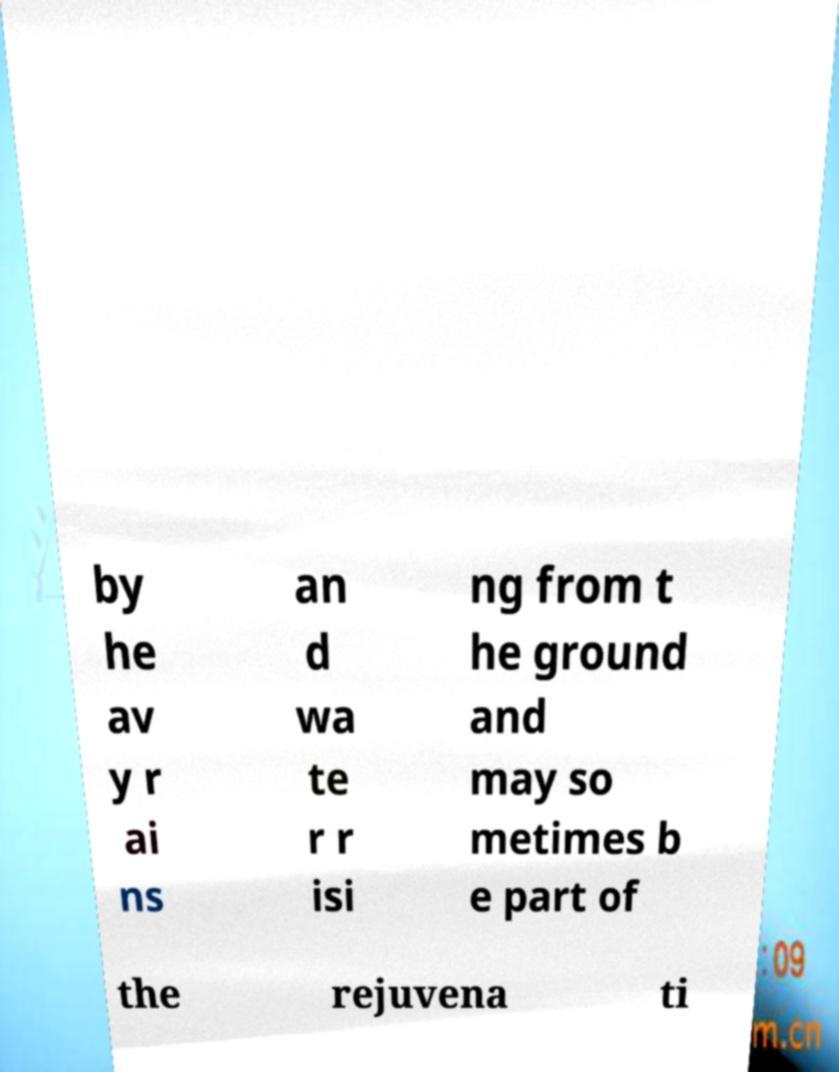For documentation purposes, I need the text within this image transcribed. Could you provide that? by he av y r ai ns an d wa te r r isi ng from t he ground and may so metimes b e part of the rejuvena ti 